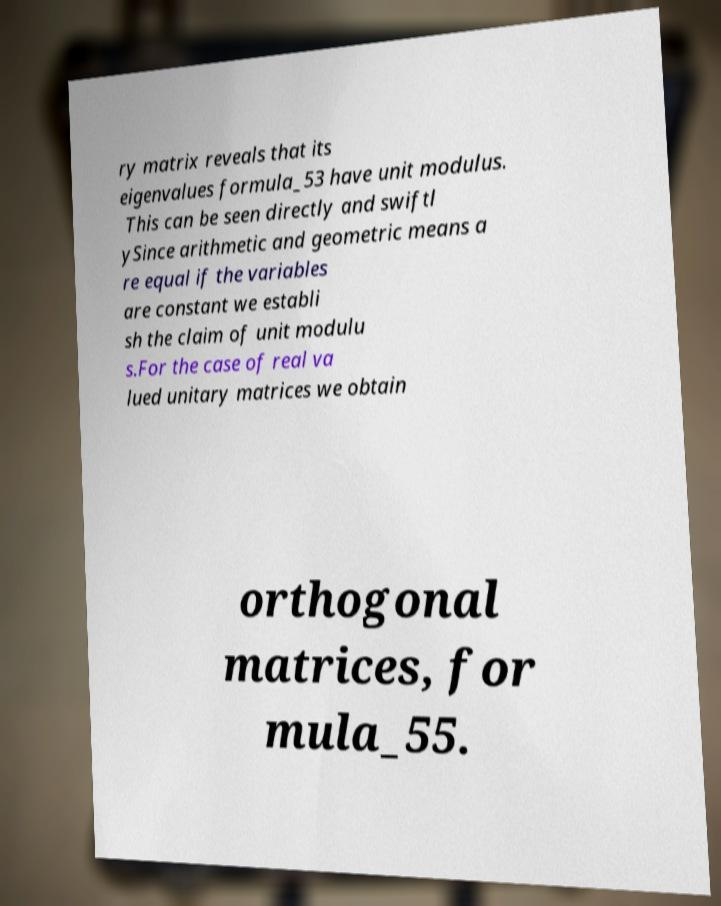Could you assist in decoding the text presented in this image and type it out clearly? ry matrix reveals that its eigenvalues formula_53 have unit modulus. This can be seen directly and swiftl ySince arithmetic and geometric means a re equal if the variables are constant we establi sh the claim of unit modulu s.For the case of real va lued unitary matrices we obtain orthogonal matrices, for mula_55. 